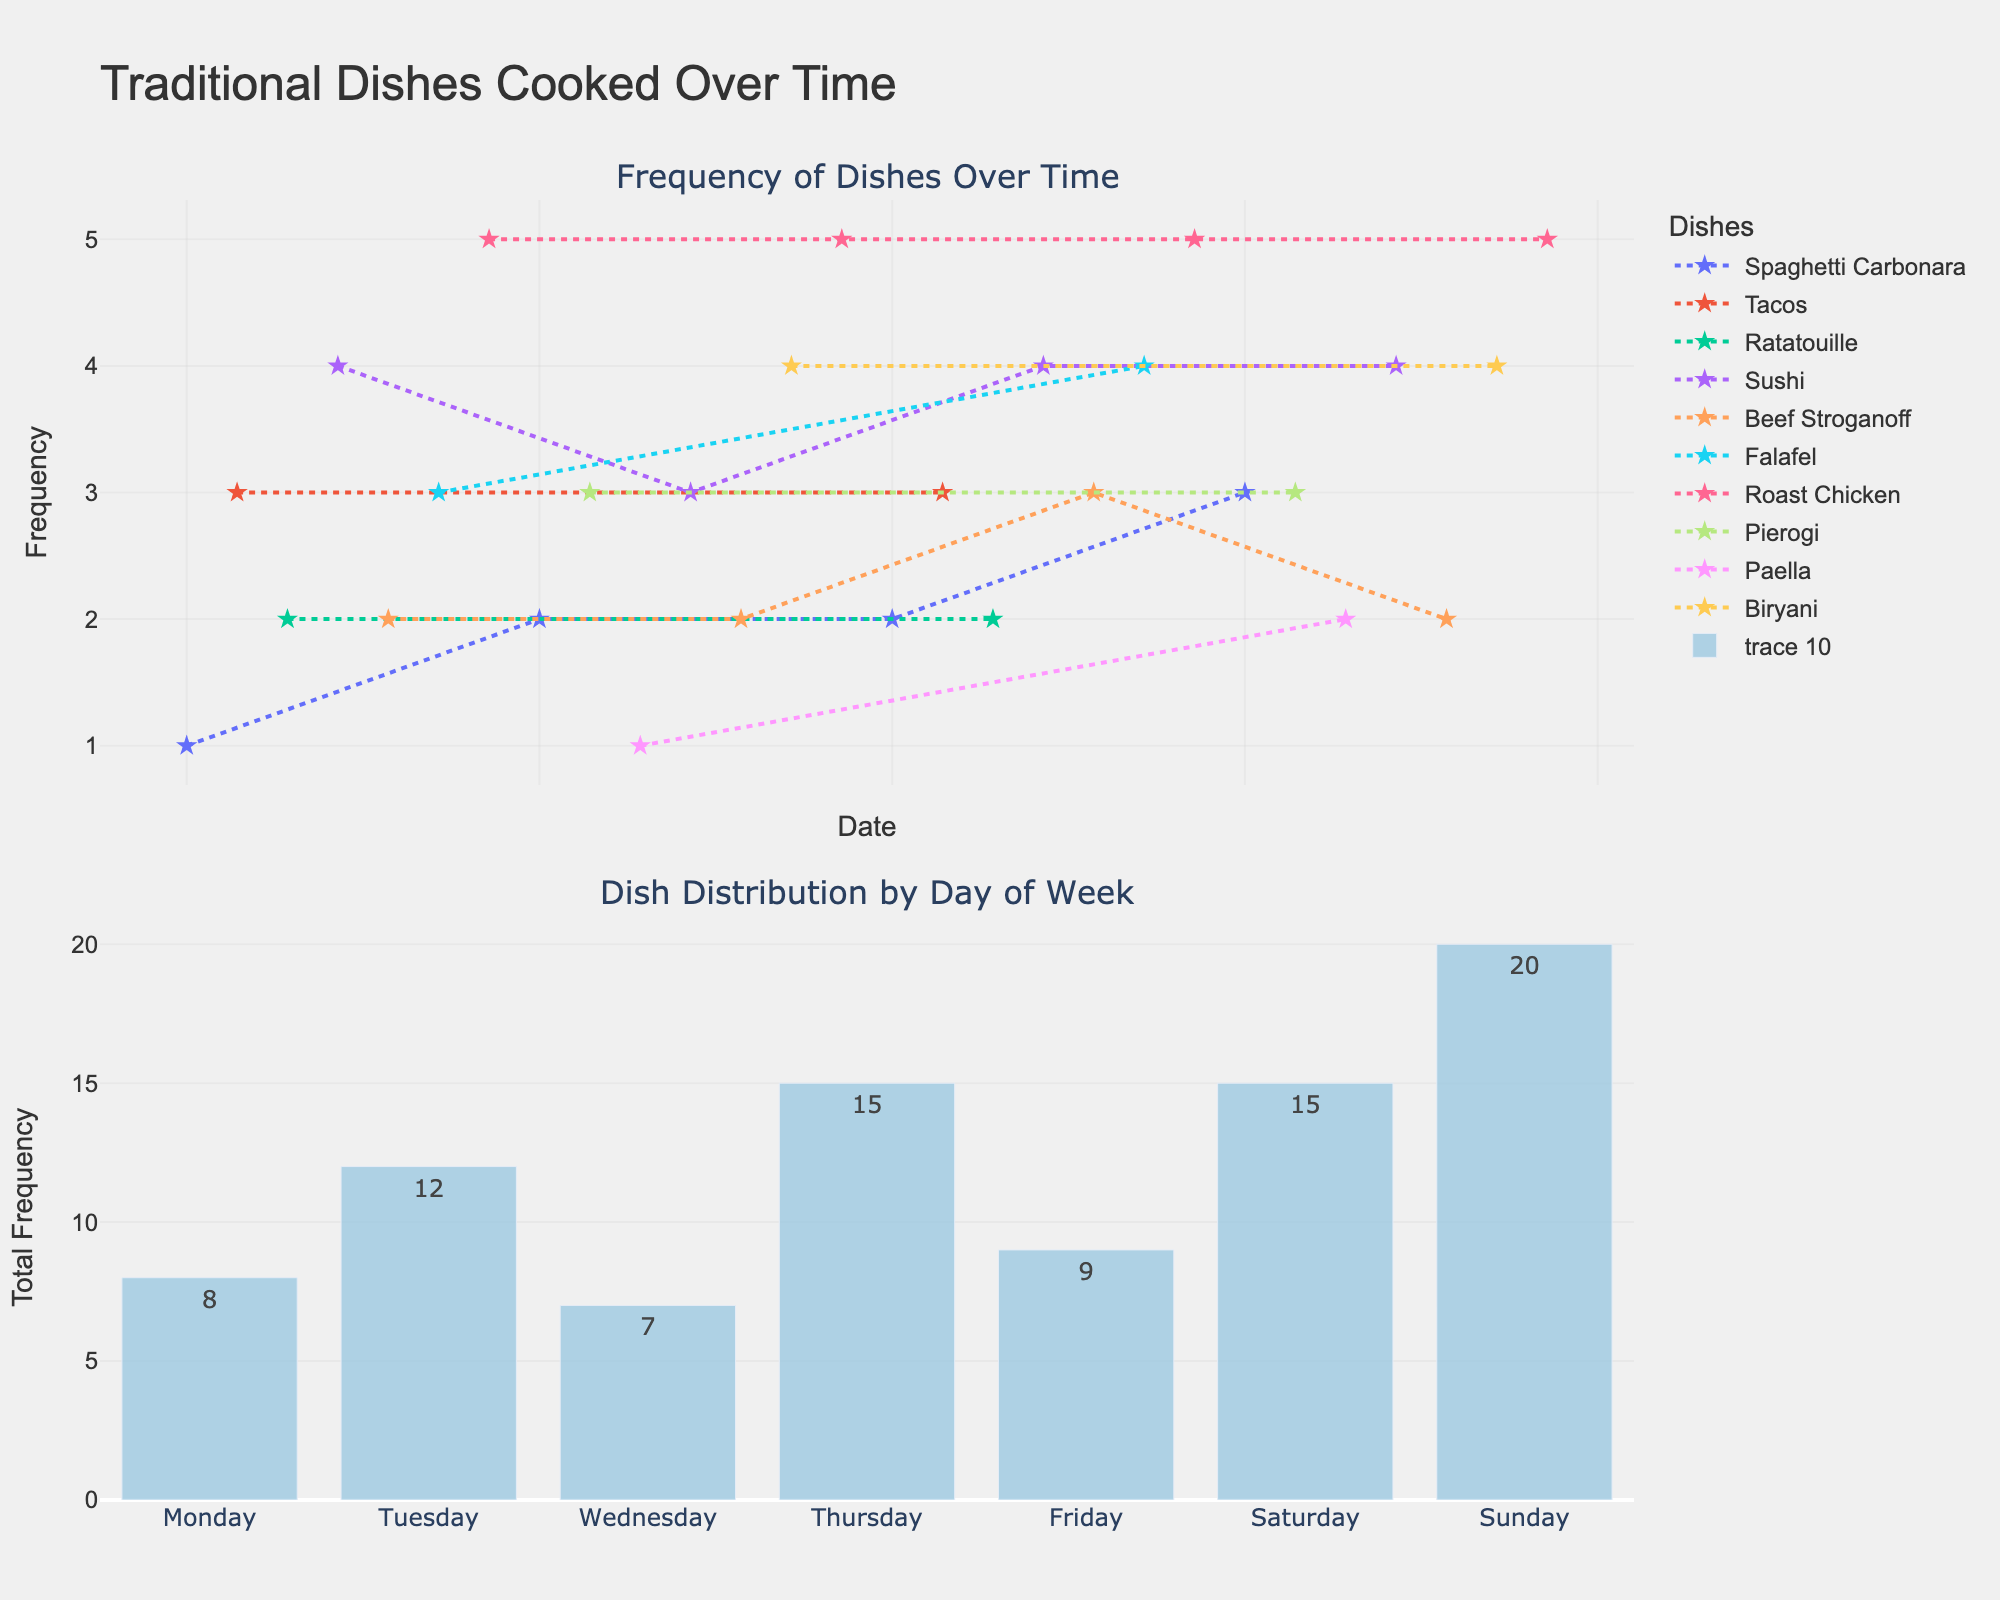What is the title of the figure? The title is usually displayed at the top of the figure. It provides a brief description of the content of the plot.
Answer: Traditional Dishes Cooked Over Time How many different types of dishes are represented in the figure? Count the unique dish names indicated in the legend or the plot itself.
Answer: 9 Which dish has the highest total frequency over time? Sum the frequencies of each dish and compare them to find the highest.
Answer: Roast Chicken On which day of the week is cooking the most frequent? Look at the bar chart in the second subplot and identify the day with the highest bar.
Answer: Sunday What is the frequency of cooking 'Sushi' on January 4th, 2023? Locate the date January 4th, 2023 on the x-axis and find the corresponding y-value for the 'Sushi' trace.
Answer: 4 Which dish is least frequently cooked on Wednesdays in this dataset? Check the frequencies of dishes cooked on Wednesdays and identify the one with the lowest frequency.
Answer: Paella How does the frequency of 'Falafel' change over the dates provided? Follow the 'Falafel' line in the time series plot and note the changes at each data point.
Answer: Increases: 3 -> 4 What is the trend of 'Spaghetti Carbonara' over time? Observe the 'Spaghetti Carbonara' line in the time series plot to identify any clear pattern or trend.
Answer: Increasing Compare the frequency of 'Roast Chicken' and 'Sushi' on January 21st, 2023. Which one is higher? Find the frequencies of both 'Roast Chicken' and 'Sushi' on January 21st, 2023 and compare them.
Answer: Roast Chicken What is the total frequency of dishes cooked on Fridays over the period shown? Sum all frequencies corresponding to Fridays in the dataset.
Answer: 11 